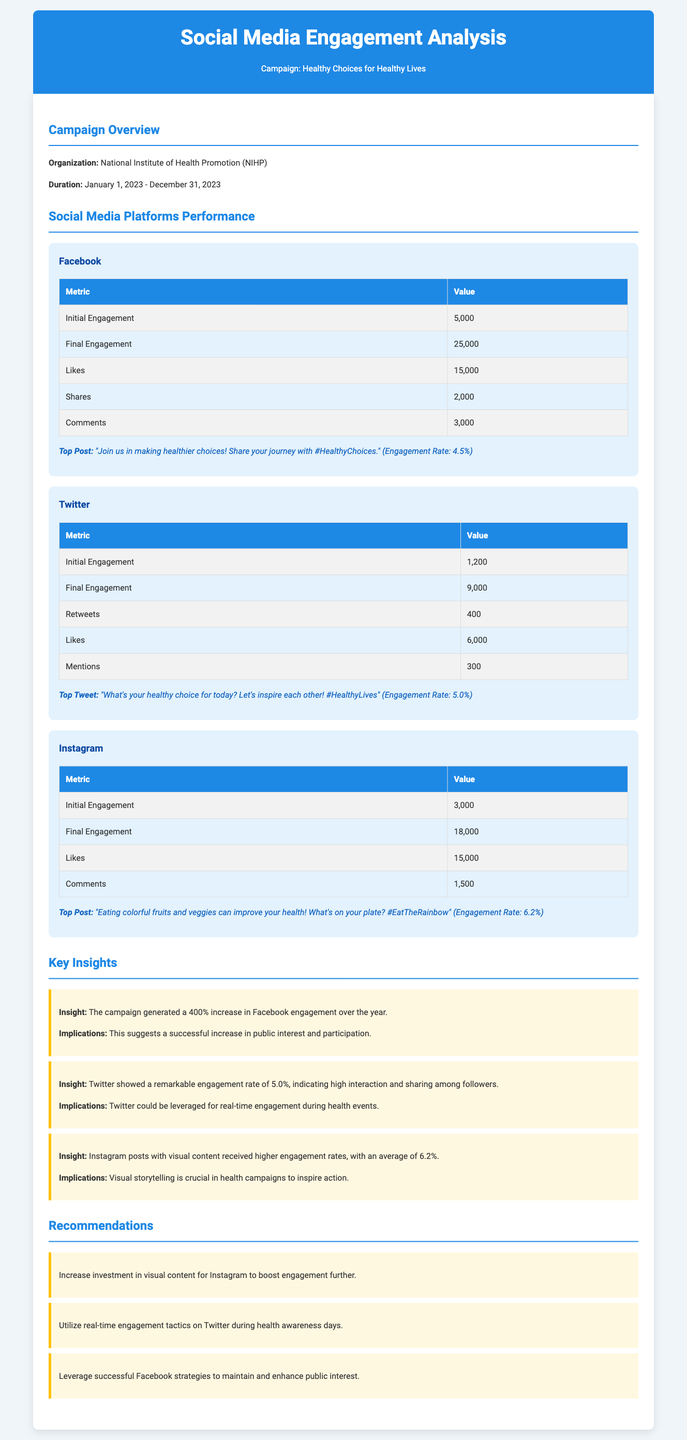what is the name of the organization behind the campaign? The document states that the organization is the National Institute of Health Promotion (NIHP).
Answer: National Institute of Health Promotion (NIHP) what is the duration of the campaign? The campaign runs from January 1, 2023, to December 31, 2023.
Answer: January 1, 2023 - December 31, 2023 what was the initial engagement on Facebook? The document provides that the initial engagement on Facebook was 5,000.
Answer: 5,000 what was the final engagement on Twitter? The final engagement metric for Twitter is stated as 9,000 in the document.
Answer: 9,000 which platform had the highest engagement rate? The insight section reveals that Instagram had the highest engagement rate of 6.2%.
Answer: 6.2% how many likes were received on Instagram? According to the document, Instagram received 15,000 likes.
Answer: 15,000 what is one recommendation made for Instagram? One of the recommendations is to increase investment in visual content for Instagram.
Answer: Increase investment in visual content what engagement increase percentage is reported for Facebook? The campaign reported a 400% increase in Facebook engagement.
Answer: 400% which post received the highest engagement rate on Twitter? The top tweet mentioned is "What's your healthy choice for today? Let's inspire each other! #HealthyLives," with an engagement rate of 5.0%.
Answer: "What's your healthy choice for today? Let's inspire each other! #HealthyLives" (5.0%) 